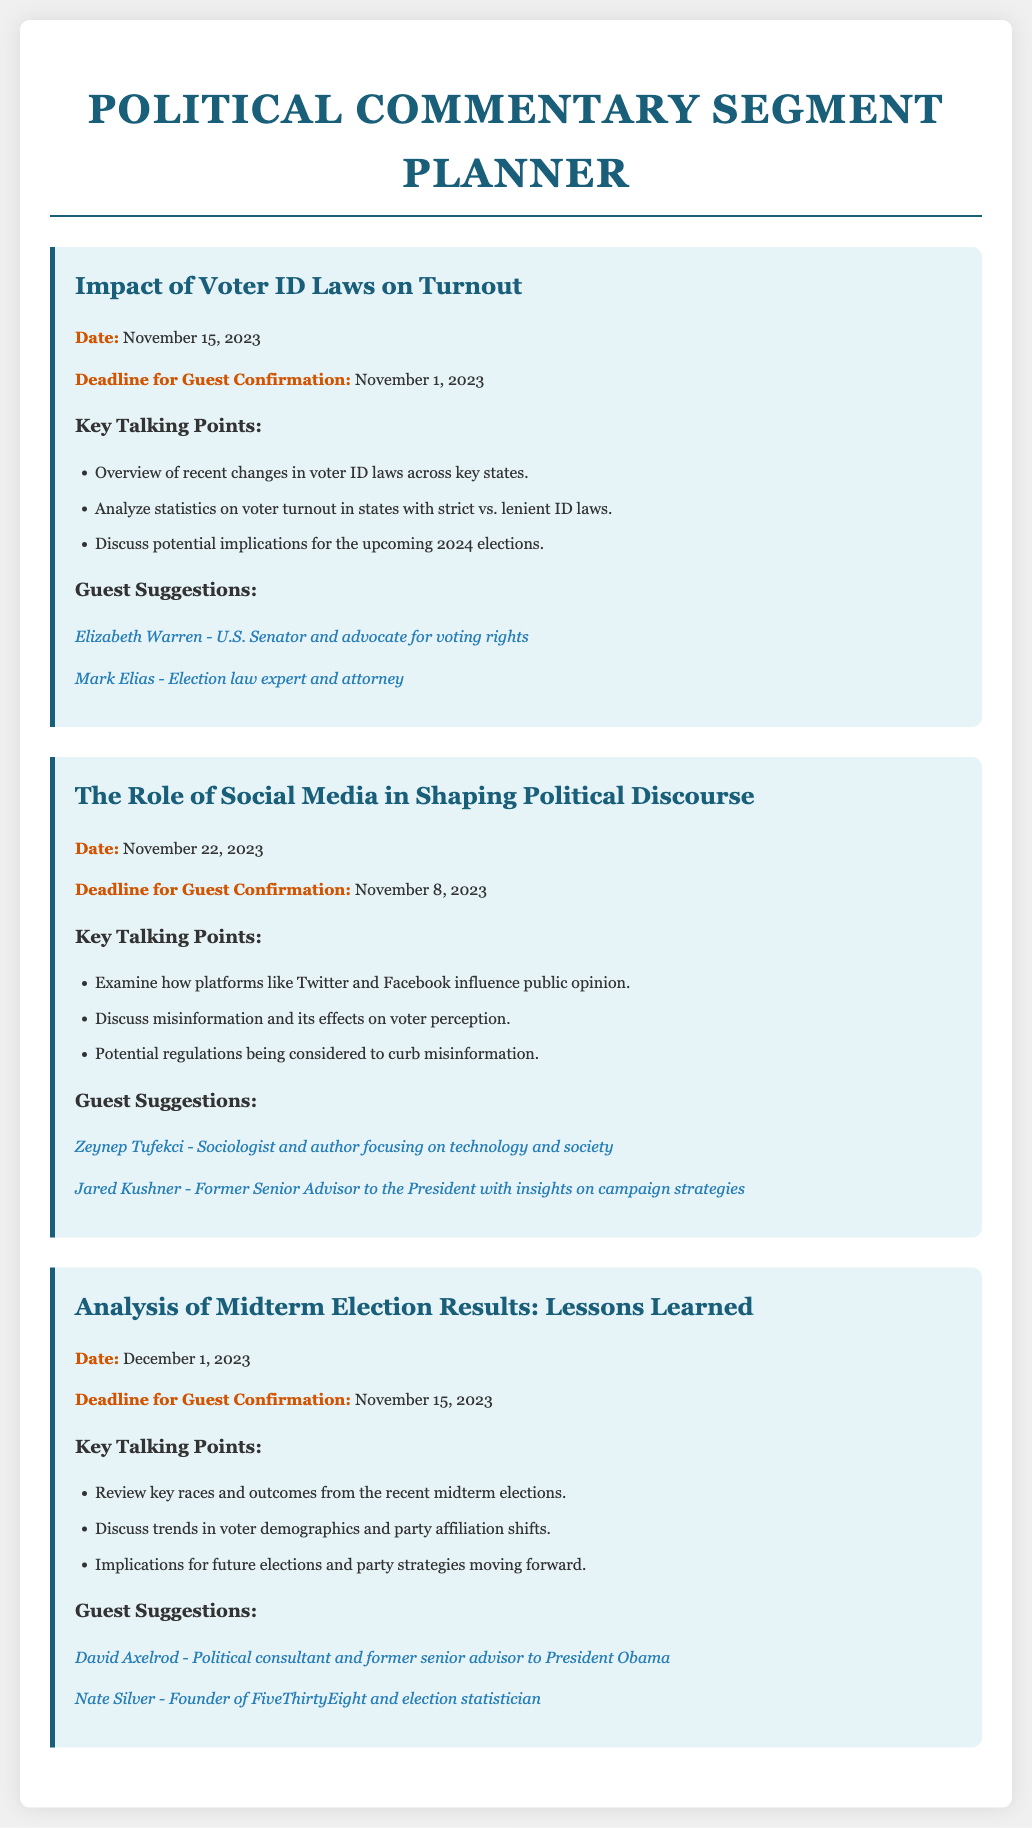What is the date of the segment discussing voter ID laws? The date is specifically mentioned under the first topic regarding voter ID laws.
Answer: November 15, 2023 What is the deadline for guest confirmation for the social media segment? The deadline is provided beneath the topic about social media influence on political discourse.
Answer: November 8, 2023 Who is suggested as a guest for the voter ID laws discussion? The document lists suggested guests for each topic, specifically for voter ID laws.
Answer: Elizabeth Warren What are the key talking points for the analysis of midterm election results? The key talking points are outlined in a list under the midterm election results topic.
Answer: Review key races and outcomes from the recent midterm elections, discuss trends in voter demographics and party affiliation shifts, implications for future elections and party strategies moving forward How many guest suggestions are provided for the social media segment? The document provides specific guest suggestions, and counting them gives the total.
Answer: Two 